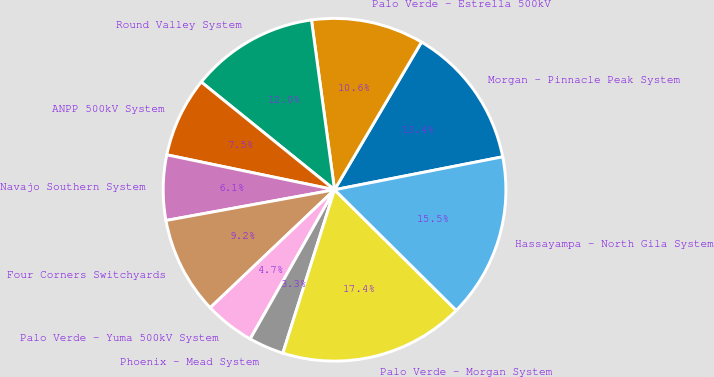Convert chart. <chart><loc_0><loc_0><loc_500><loc_500><pie_chart><fcel>Morgan - Pinnacle Peak System<fcel>Palo Verde - Estrella 500kV<fcel>Round Valley System<fcel>ANPP 500kV System<fcel>Navajo Southern System<fcel>Four Corners Switchyards<fcel>Palo Verde - Yuma 500kV System<fcel>Phoenix - Mead System<fcel>Palo Verde - Morgan System<fcel>Hassayampa - North Gila System<nl><fcel>13.45%<fcel>10.62%<fcel>12.03%<fcel>7.55%<fcel>6.14%<fcel>9.21%<fcel>4.73%<fcel>3.31%<fcel>17.45%<fcel>15.51%<nl></chart> 